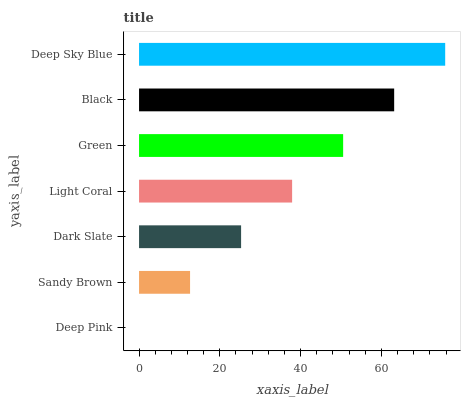Is Deep Pink the minimum?
Answer yes or no. Yes. Is Deep Sky Blue the maximum?
Answer yes or no. Yes. Is Sandy Brown the minimum?
Answer yes or no. No. Is Sandy Brown the maximum?
Answer yes or no. No. Is Sandy Brown greater than Deep Pink?
Answer yes or no. Yes. Is Deep Pink less than Sandy Brown?
Answer yes or no. Yes. Is Deep Pink greater than Sandy Brown?
Answer yes or no. No. Is Sandy Brown less than Deep Pink?
Answer yes or no. No. Is Light Coral the high median?
Answer yes or no. Yes. Is Light Coral the low median?
Answer yes or no. Yes. Is Dark Slate the high median?
Answer yes or no. No. Is Deep Sky Blue the low median?
Answer yes or no. No. 